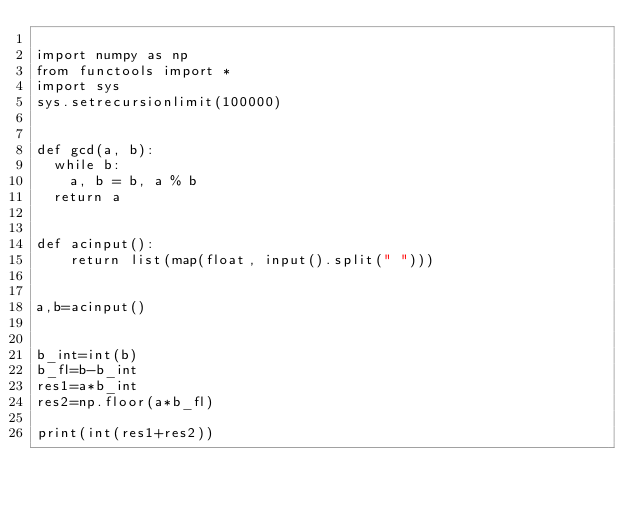Convert code to text. <code><loc_0><loc_0><loc_500><loc_500><_Python_>
import numpy as np
from functools import *
import sys
sys.setrecursionlimit(100000)


def gcd(a, b):
	while b:
		a, b = b, a % b
	return a


def acinput():
    return list(map(float, input().split(" ")))


a,b=acinput()


b_int=int(b)
b_fl=b-b_int
res1=a*b_int
res2=np.floor(a*b_fl)

print(int(res1+res2))
</code> 